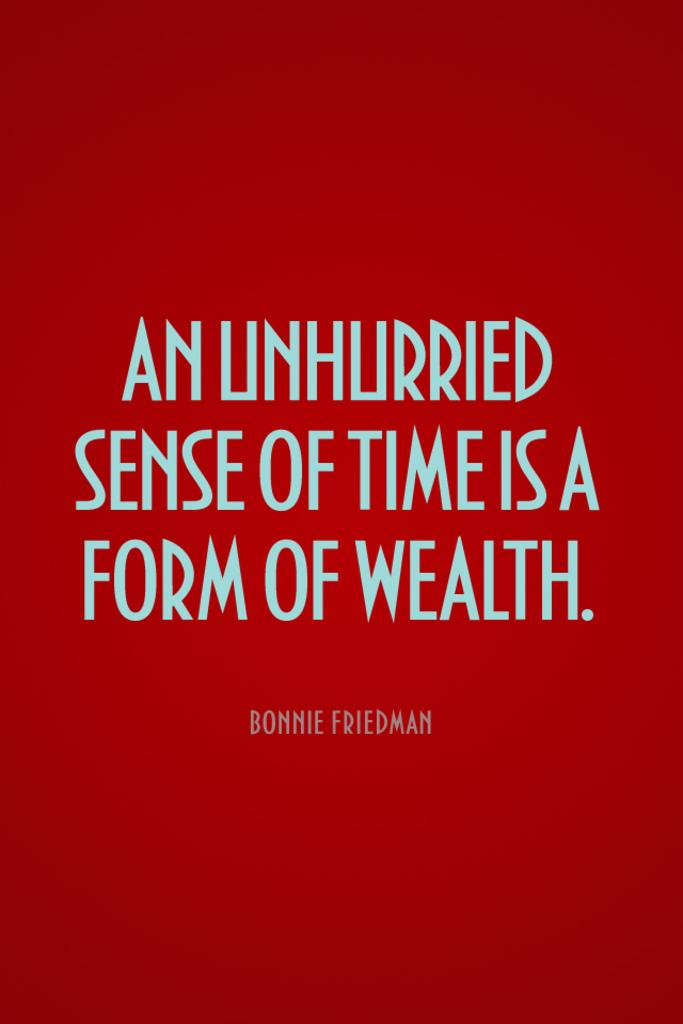<image>
Share a concise interpretation of the image provided. An Unhurried Sense of Time is A Form of Wealth against a red back drop. 